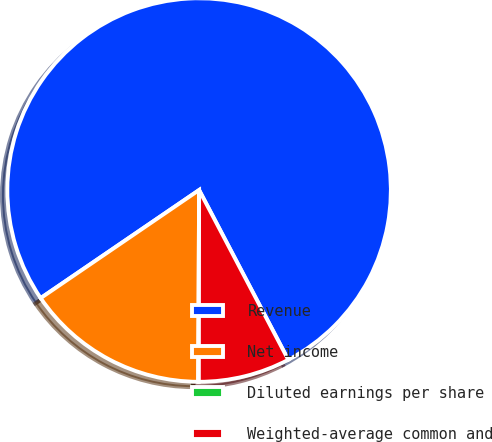Convert chart. <chart><loc_0><loc_0><loc_500><loc_500><pie_chart><fcel>Revenue<fcel>Net income<fcel>Diluted earnings per share<fcel>Weighted-average common and<nl><fcel>76.83%<fcel>15.4%<fcel>0.05%<fcel>7.72%<nl></chart> 